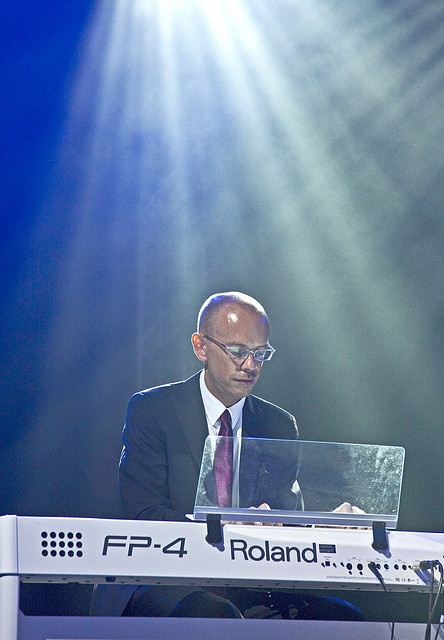Describe the objects in this image and their specific colors. I can see people in blue, darkblue, navy, gray, and darkgray tones, tie in blue, gray, purple, and navy tones, and tie in blue, navy, and purple tones in this image. 